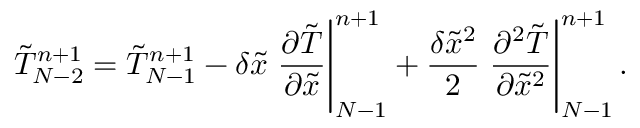<formula> <loc_0><loc_0><loc_500><loc_500>\tilde { T } _ { N - 2 } ^ { n + 1 } = \tilde { T } _ { N - 1 } ^ { n + 1 } - \delta \tilde { x } { \frac { { \partial \tilde { T } } } { { \partial \tilde { x } } } } \right | _ { N - 1 } ^ { n + 1 } + \frac { { \delta { { \tilde { x } } ^ { 2 } } } } { 2 } { \frac { { { \partial ^ { 2 } } \tilde { T } } } { { \partial { { \tilde { x } } ^ { 2 } } } } } \right | _ { N - 1 } ^ { n + 1 } .</formula> 